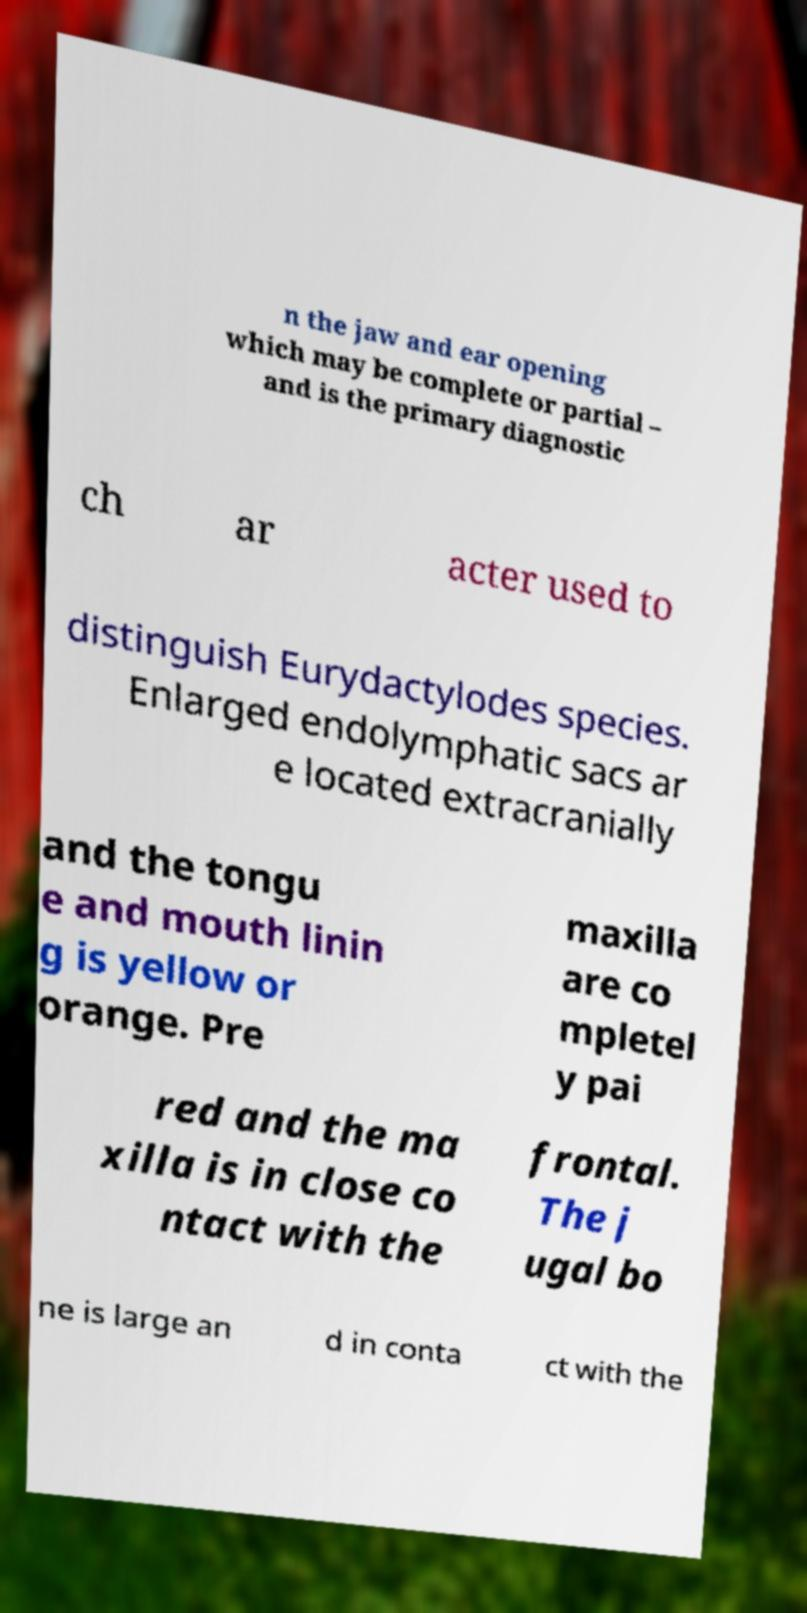Can you accurately transcribe the text from the provided image for me? n the jaw and ear opening which may be complete or partial – and is the primary diagnostic ch ar acter used to distinguish Eurydactylodes species. Enlarged endolymphatic sacs ar e located extracranially and the tongu e and mouth linin g is yellow or orange. Pre maxilla are co mpletel y pai red and the ma xilla is in close co ntact with the frontal. The j ugal bo ne is large an d in conta ct with the 